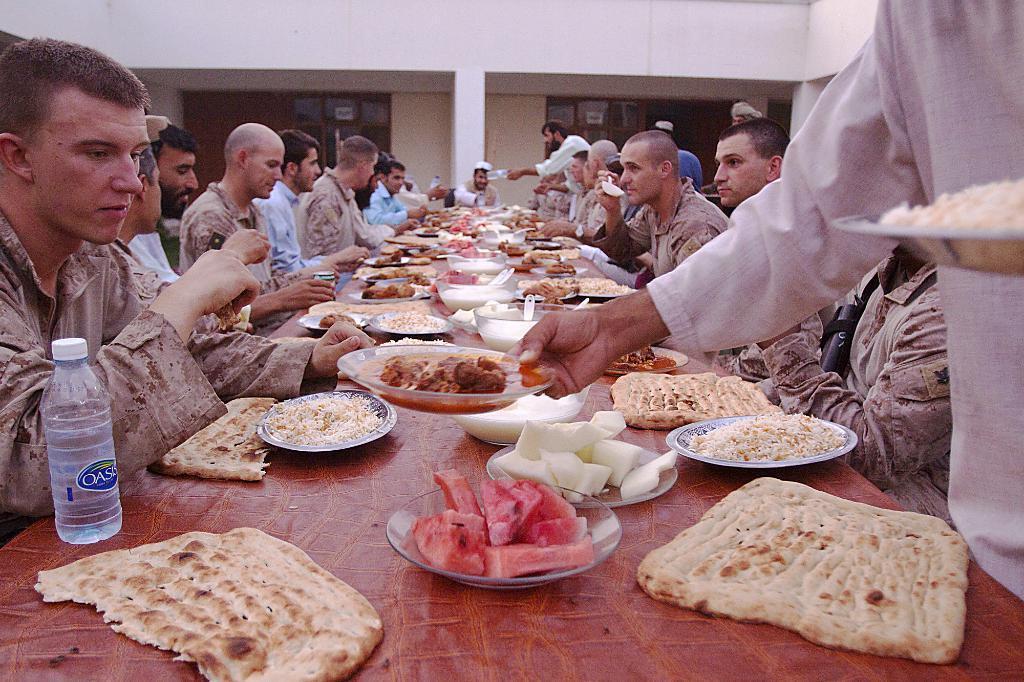Can you describe this image briefly? In this picture I can observe some people sitting in the chairs in front of a long table. There are some food items placed on the table. This table is in brown color. I can observe some bowls and water bottles placed on the table. In the background I can observe white color pillar and a wall. 